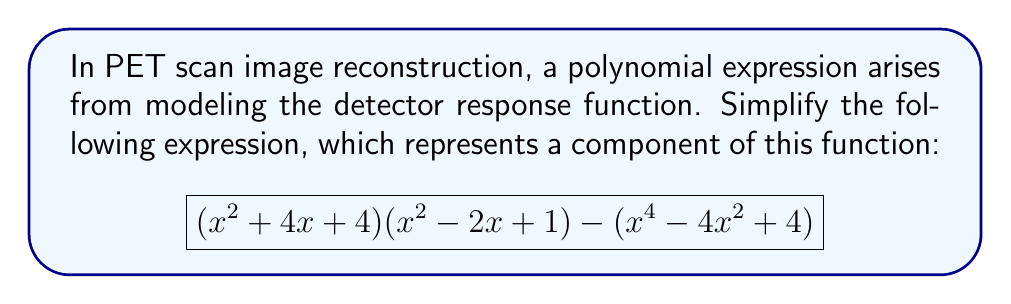Could you help me with this problem? Let's approach this step-by-step:

1) First, let's expand $(x^2 + 4x + 4)(x^2 - 2x + 1)$:
   $$(x^2 + 4x + 4)(x^2 - 2x + 1) = x^4 - 2x^3 + x^2 + 4x^3 - 8x^2 + 4x + 4x^2 - 8x + 4$$
   $$= x^4 + 2x^3 - 3x^2 - 4x + 4$$

2) Now our expression looks like:
   $$(x^4 + 2x^3 - 3x^2 - 4x + 4) - (x^4 - 4x^2 + 4)$$

3) Let's subtract the second polynomial from the first:
   $$x^4 + 2x^3 - 3x^2 - 4x + 4$$
   $$- (x^4 - 4x^2 + 4)$$
   $$= 2x^3 + x^2 - 4x$$

4) This is our simplified polynomial. We can factor out the greatest common factor:
   $$2x^3 + x^2 - 4x = x(2x^2 + x - 4)$$

5) The quadratic factor $(2x^2 + x - 4)$ can be further factored:
   $$x(2x^2 + x - 4) = x(2x - 2)(x + 2) = 2x(x - 1)(x + 2)$$

Thus, the fully factored and simplified expression is $2x(x - 1)(x + 2)$.
Answer: $2x(x - 1)(x + 2)$ 